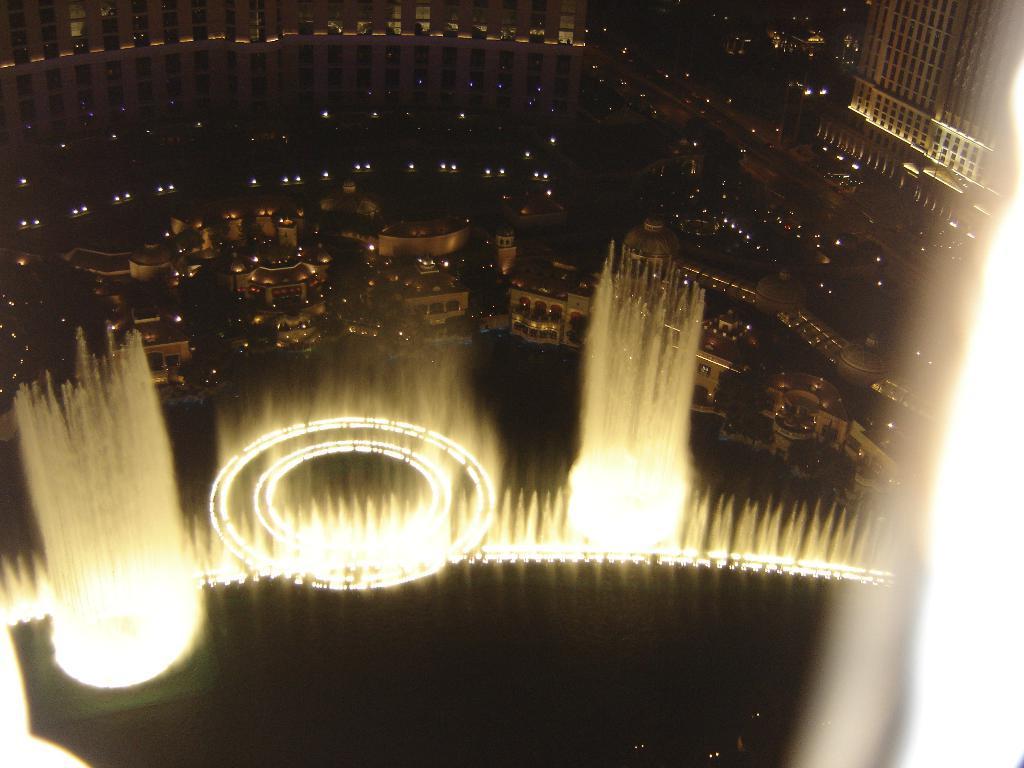In one or two sentences, can you explain what this image depicts? Here in this picture we can see an aerial view, in which we can see number of buildings present over a place and we in the front we can see water fountains which are covered with lights present. 